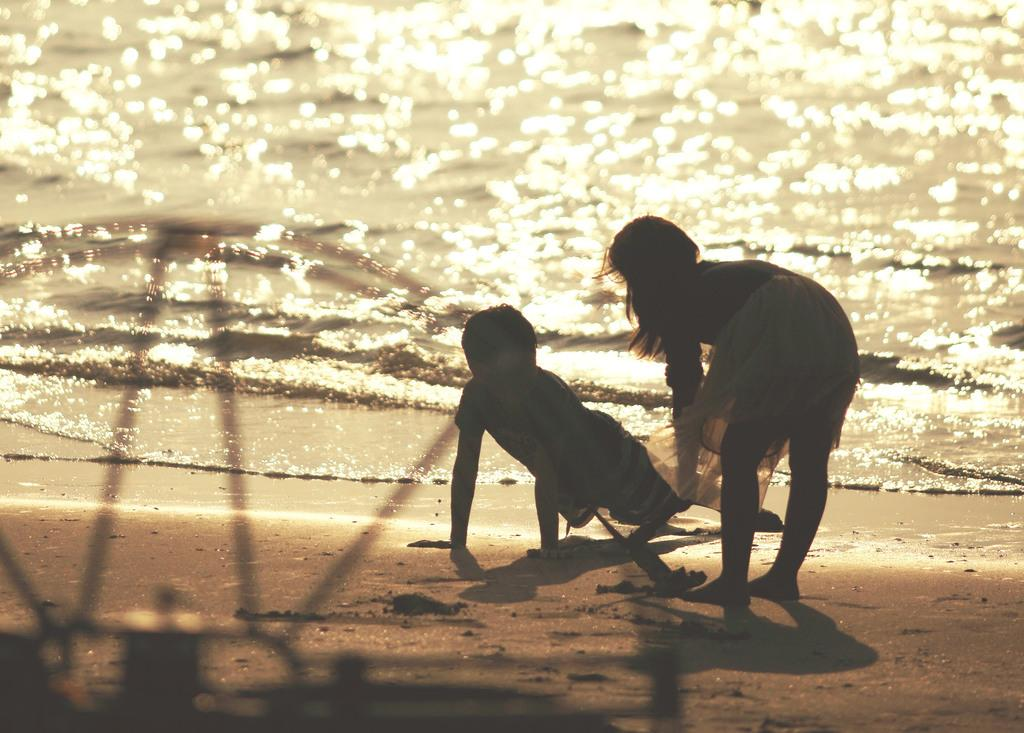Who is present in the image? There are kids in the image. What can be seen at the bottom of the image? There is water and sand visible at the bottom of the image. What type of cannon is being used by the mother in the image? There is no mother or cannon present in the image. How does the ice affect the kids' activities in the image? There is no ice present in the image, so its effect on the kids' activities cannot be determined. 